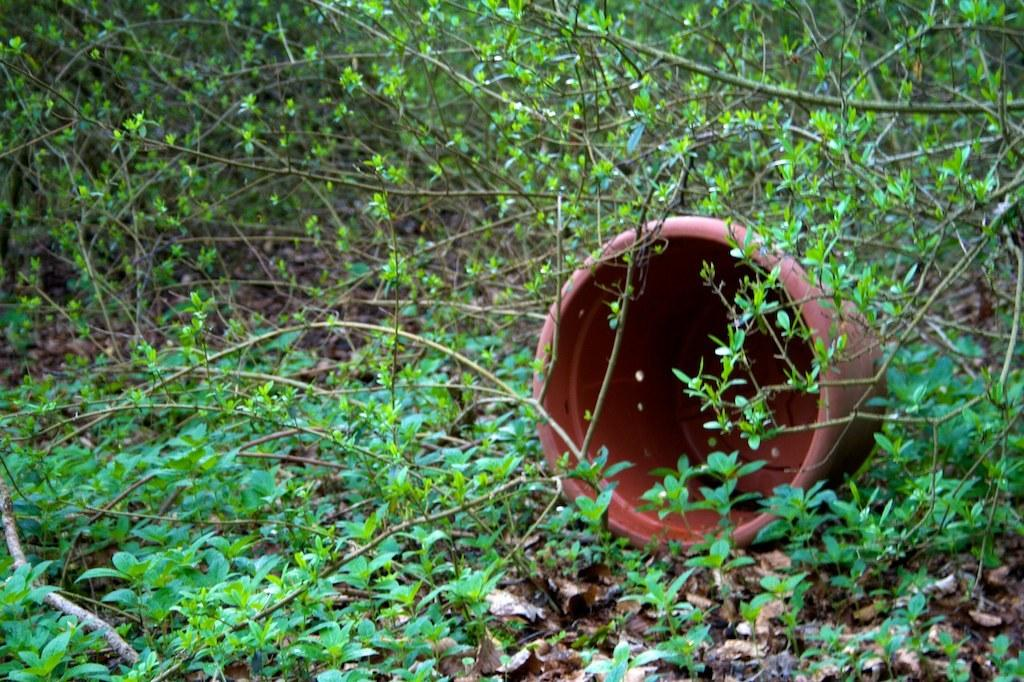What object is present on the ground in the image? There is a flower pot in the image, and it is on the ground. What is the color of the flower pot? The flower pot is brown in color. What type of vegetation can be seen in the image? There are plants in the image, and they are green in color. What part of the plants can be seen in the image? There are leaves in the image, and they are brown in color. Where are the leaves located in the image? The leaves are on the ground in the image. What type of tax is being discussed in the image? There is no discussion of tax in the image; it features a flower pot, plants, and leaves. What type of dress is being worn by the plant in the image? There is no plant wearing a dress in the image; plants do not wear clothing. 